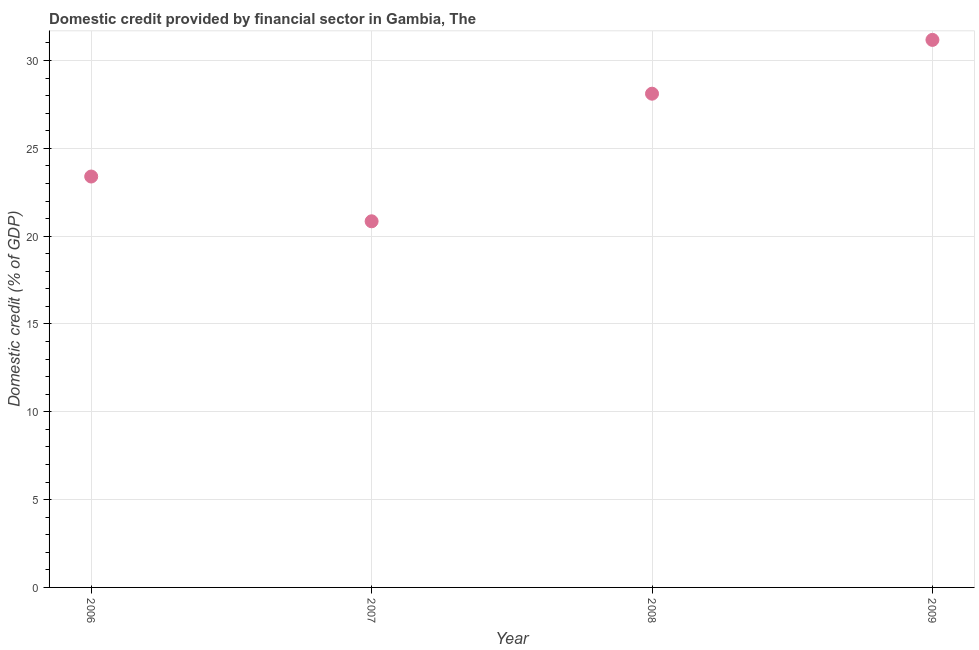What is the domestic credit provided by financial sector in 2009?
Your response must be concise. 31.17. Across all years, what is the maximum domestic credit provided by financial sector?
Offer a terse response. 31.17. Across all years, what is the minimum domestic credit provided by financial sector?
Give a very brief answer. 20.85. In which year was the domestic credit provided by financial sector maximum?
Ensure brevity in your answer.  2009. What is the sum of the domestic credit provided by financial sector?
Make the answer very short. 103.52. What is the difference between the domestic credit provided by financial sector in 2007 and 2008?
Give a very brief answer. -7.26. What is the average domestic credit provided by financial sector per year?
Provide a short and direct response. 25.88. What is the median domestic credit provided by financial sector?
Your answer should be compact. 25.75. Do a majority of the years between 2009 and 2007 (inclusive) have domestic credit provided by financial sector greater than 20 %?
Your answer should be compact. No. What is the ratio of the domestic credit provided by financial sector in 2007 to that in 2009?
Offer a very short reply. 0.67. What is the difference between the highest and the second highest domestic credit provided by financial sector?
Keep it short and to the point. 3.06. Is the sum of the domestic credit provided by financial sector in 2006 and 2008 greater than the maximum domestic credit provided by financial sector across all years?
Make the answer very short. Yes. What is the difference between the highest and the lowest domestic credit provided by financial sector?
Your answer should be very brief. 10.33. Does the domestic credit provided by financial sector monotonically increase over the years?
Your response must be concise. No. How many years are there in the graph?
Keep it short and to the point. 4. What is the difference between two consecutive major ticks on the Y-axis?
Provide a short and direct response. 5. Does the graph contain any zero values?
Provide a short and direct response. No. Does the graph contain grids?
Keep it short and to the point. Yes. What is the title of the graph?
Make the answer very short. Domestic credit provided by financial sector in Gambia, The. What is the label or title of the X-axis?
Ensure brevity in your answer.  Year. What is the label or title of the Y-axis?
Make the answer very short. Domestic credit (% of GDP). What is the Domestic credit (% of GDP) in 2006?
Ensure brevity in your answer.  23.39. What is the Domestic credit (% of GDP) in 2007?
Keep it short and to the point. 20.85. What is the Domestic credit (% of GDP) in 2008?
Keep it short and to the point. 28.11. What is the Domestic credit (% of GDP) in 2009?
Your answer should be very brief. 31.17. What is the difference between the Domestic credit (% of GDP) in 2006 and 2007?
Ensure brevity in your answer.  2.55. What is the difference between the Domestic credit (% of GDP) in 2006 and 2008?
Offer a very short reply. -4.72. What is the difference between the Domestic credit (% of GDP) in 2006 and 2009?
Provide a succinct answer. -7.78. What is the difference between the Domestic credit (% of GDP) in 2007 and 2008?
Offer a very short reply. -7.26. What is the difference between the Domestic credit (% of GDP) in 2007 and 2009?
Make the answer very short. -10.33. What is the difference between the Domestic credit (% of GDP) in 2008 and 2009?
Keep it short and to the point. -3.06. What is the ratio of the Domestic credit (% of GDP) in 2006 to that in 2007?
Your answer should be compact. 1.12. What is the ratio of the Domestic credit (% of GDP) in 2006 to that in 2008?
Provide a short and direct response. 0.83. What is the ratio of the Domestic credit (% of GDP) in 2007 to that in 2008?
Provide a succinct answer. 0.74. What is the ratio of the Domestic credit (% of GDP) in 2007 to that in 2009?
Provide a short and direct response. 0.67. What is the ratio of the Domestic credit (% of GDP) in 2008 to that in 2009?
Your response must be concise. 0.9. 